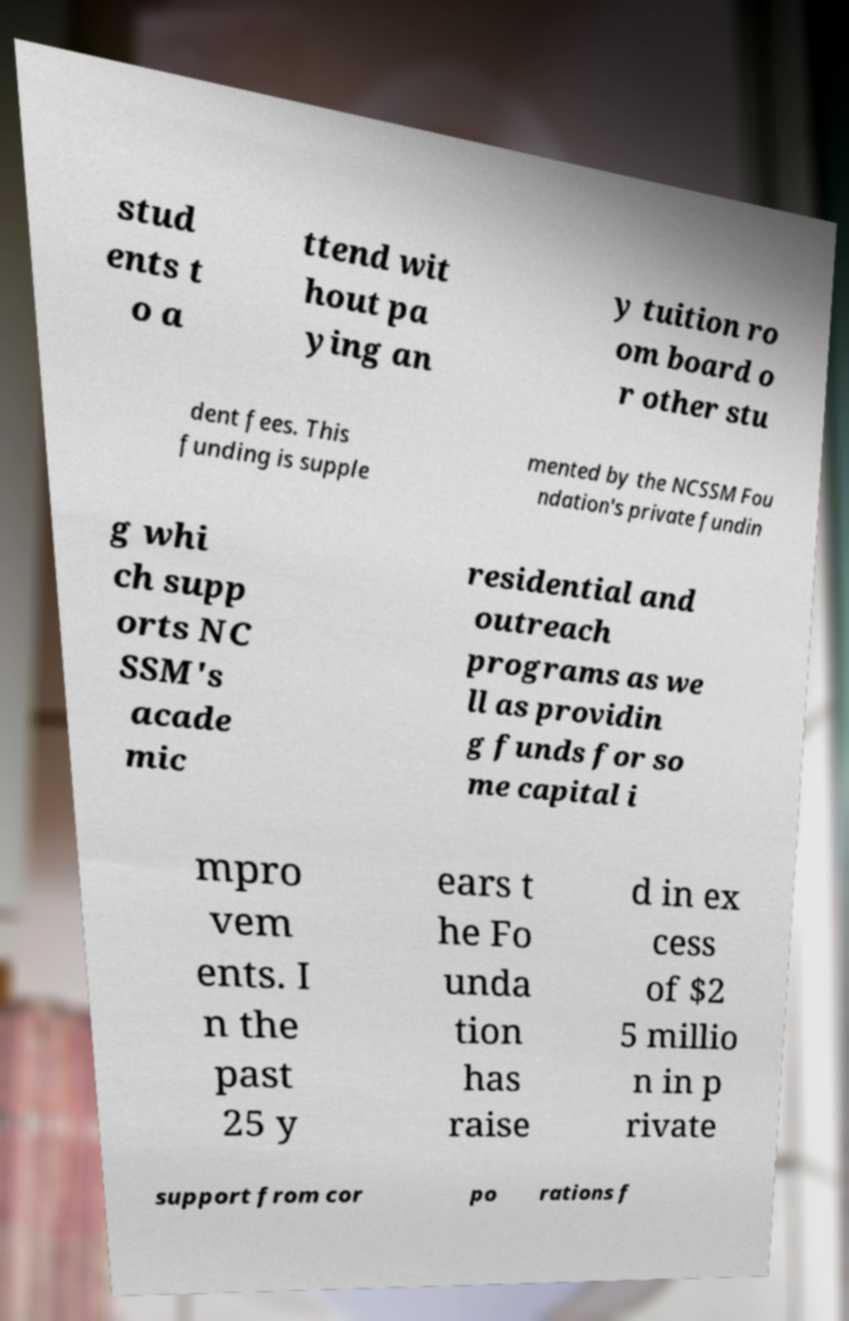For documentation purposes, I need the text within this image transcribed. Could you provide that? stud ents t o a ttend wit hout pa ying an y tuition ro om board o r other stu dent fees. This funding is supple mented by the NCSSM Fou ndation's private fundin g whi ch supp orts NC SSM's acade mic residential and outreach programs as we ll as providin g funds for so me capital i mpro vem ents. I n the past 25 y ears t he Fo unda tion has raise d in ex cess of $2 5 millio n in p rivate support from cor po rations f 